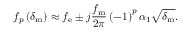Convert formula to latex. <formula><loc_0><loc_0><loc_500><loc_500>f _ { p } \left ( \delta _ { m } \right ) \approx f _ { e } \pm j \frac { f _ { m } } { 2 \pi } \left ( - 1 \right ) ^ { p } \alpha _ { 1 } \sqrt { \delta _ { m } } .</formula> 